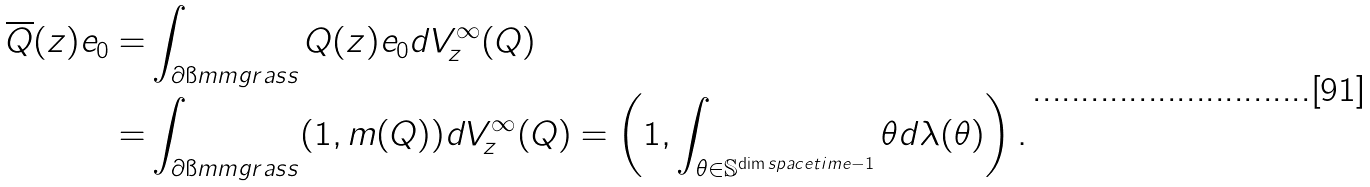<formula> <loc_0><loc_0><loc_500><loc_500>\overline { Q } ( z ) e _ { 0 } = & \int _ { \partial \i m m g r a s s } Q ( z ) e _ { 0 } d V ^ { \infty } _ { z } ( Q ) \\ = & \int _ { \partial \i m m g r a s s } ( 1 , m ( Q ) ) d V ^ { \infty } _ { z } ( Q ) = \left ( 1 , \int _ { \theta \in \mathbb { S } ^ { \dim s p a c e t i m e - 1 } } \theta d \lambda ( \theta ) \right ) .</formula> 